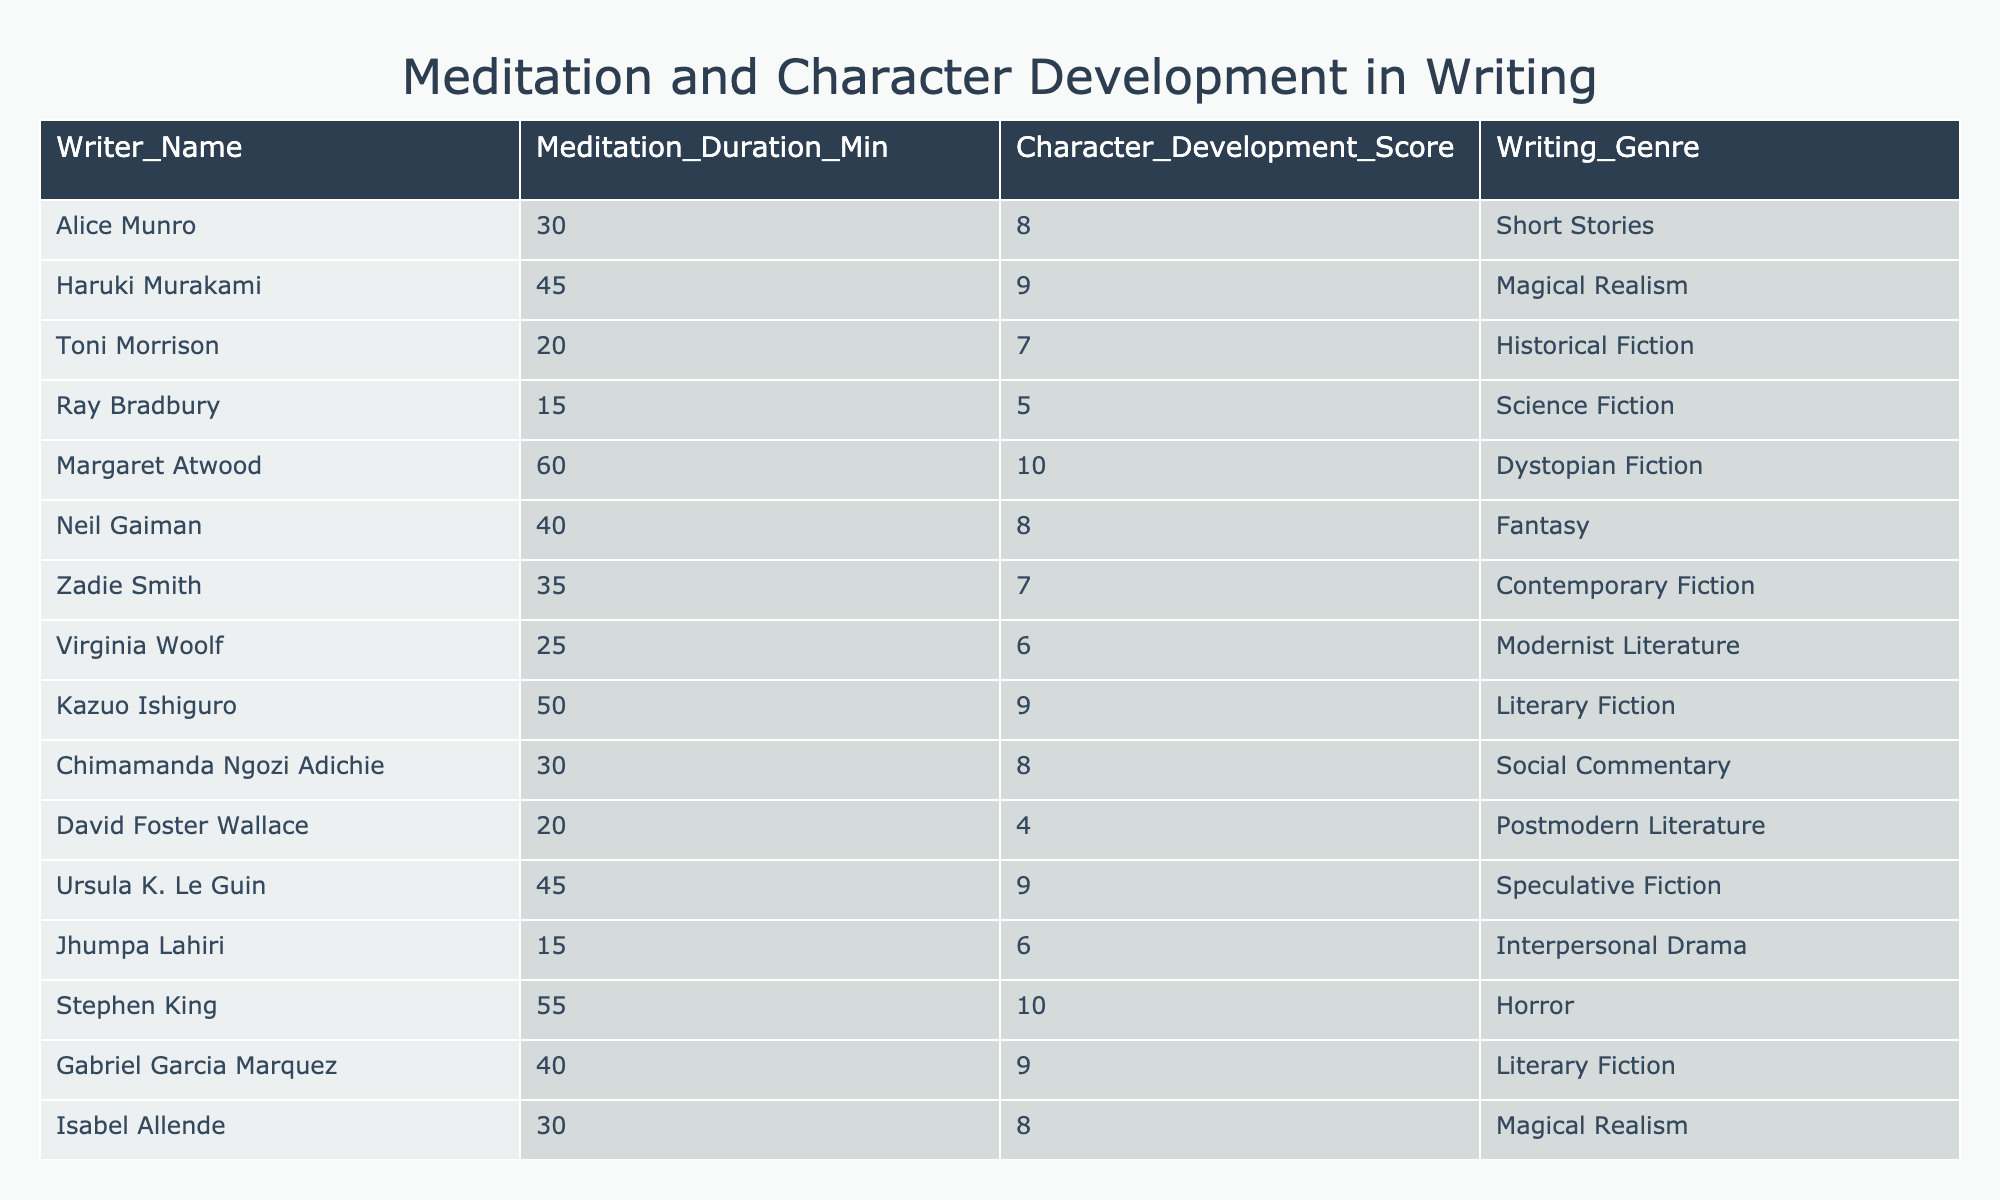What is the meditation duration of Stephen King? The table lists Stephen King in the rows, and his meditation duration is clearly stated as 55 minutes.
Answer: 55 minutes Who has the highest character development score? By examining the character development scores in the table, both Margaret Atwood and Stephen King have the highest score of 10.
Answer: Margaret Atwood and Stephen King What is the average meditation duration for the writers? To calculate the average, sum all meditation durations: (30 + 45 + 20 + 15 + 60 + 40 + 35 + 25 + 50 + 30 + 20 + 45 + 15 + 55 + 40 + 30) =  630. There are 16 writers, so the average is 630 / 16 = 39.375.
Answer: 39.375 minutes Is there a writer who meditates for 20 minutes? Checking the table, I see that both Toni Morrison and David Foster Wallace meditate for exactly 20 minutes. Thus, the statement is true.
Answer: Yes Which genres correspond to the highest character development scores? The highest scores, 10, correspond to Dystopian Fiction (Margaret Atwood) and Horror (Stephen King). So, these two genres relate directly to the highest character development scores.
Answer: Dystopian Fiction and Horror What is the difference in meditation duration between the least and most meditative writers? The writer with the least meditation duration is Ray Bradbury at 15 minutes, and the writer with the most is Margaret Atwood at 60 minutes. Thus, the difference is 60 - 15 = 45 minutes.
Answer: 45 minutes Are there more writers in the genre of Magical Realism or Fantasy? The table shows that there are two writers in Magical Realism (Haruki Murakami and Isabel Allende) and one in Fantasy (Neil Gaiman). Therefore, there are more in Magical Realism.
Answer: More in Magical Realism What is the total character development score for writers who meditate for 45 minutes or more? The writers that meditate for 45 minutes or more are Haruki Murakami (9), Margaret Atwood (10), Neil Gaiman (8), Ursula K. Le Guin (9), Stephen King (10), and Gabriel Garcia Marquez (9). Adding these scores together gives 9 + 10 + 8 + 9 + 10 + 9 = 55.
Answer: 55 Which writer has a character development score greater than 8 and meditates for 30 minutes or less? Searching through the table, I find that no writers who meditate for 30 minutes or less (Alice Munro, Toni Morrison, Zadie Smith, Virginia Woolf, and David Foster Wallace) have a character development score greater than 8. Therefore, there is no match.
Answer: No match What can be deduced about meditation duration and writing genres with higher character development scores? On analyzing the tables, it can be observed that genres like Dystopian Fiction and Horror, which have the highest character development scores of 10, also have higher meditation durations (60 minutes for Atwood and 55 minutes for King). This suggests a potential correlation.
Answer: Higher meditation may relate to higher scores 